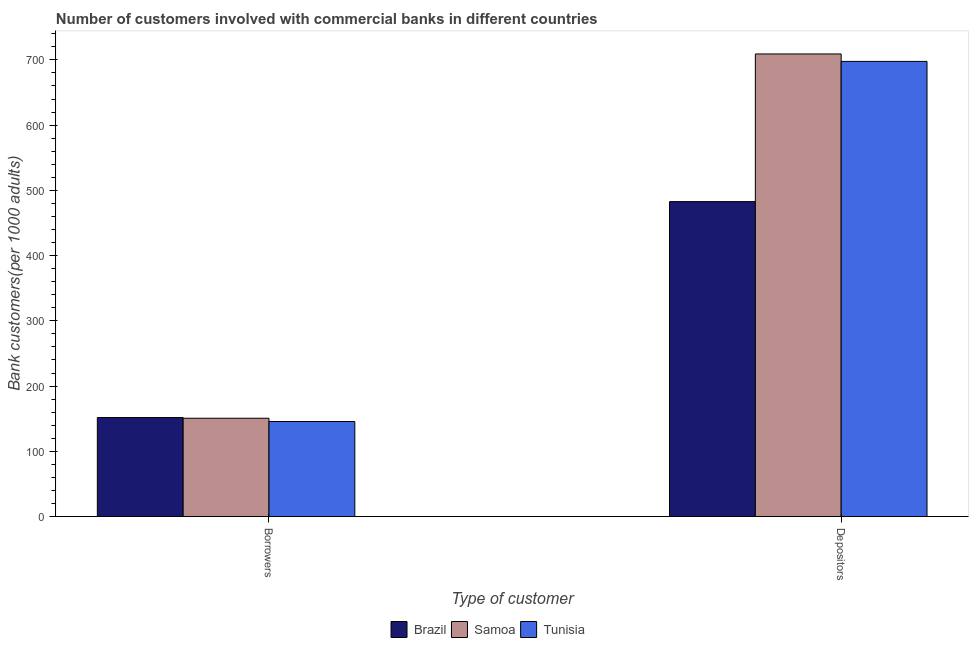How many different coloured bars are there?
Your answer should be very brief. 3. Are the number of bars on each tick of the X-axis equal?
Your answer should be very brief. Yes. What is the label of the 1st group of bars from the left?
Keep it short and to the point. Borrowers. What is the number of depositors in Samoa?
Your answer should be very brief. 709.09. Across all countries, what is the maximum number of borrowers?
Offer a very short reply. 151.74. Across all countries, what is the minimum number of borrowers?
Provide a short and direct response. 145.68. In which country was the number of depositors maximum?
Give a very brief answer. Samoa. In which country was the number of borrowers minimum?
Offer a very short reply. Tunisia. What is the total number of depositors in the graph?
Provide a short and direct response. 1889.51. What is the difference between the number of borrowers in Samoa and that in Tunisia?
Your response must be concise. 5. What is the difference between the number of borrowers in Samoa and the number of depositors in Brazil?
Your response must be concise. -332.06. What is the average number of depositors per country?
Offer a terse response. 629.84. What is the difference between the number of borrowers and number of depositors in Brazil?
Your answer should be very brief. -331. In how many countries, is the number of borrowers greater than 720 ?
Your answer should be very brief. 0. What is the ratio of the number of borrowers in Tunisia to that in Samoa?
Your answer should be compact. 0.97. Is the number of borrowers in Samoa less than that in Tunisia?
Provide a short and direct response. No. In how many countries, is the number of borrowers greater than the average number of borrowers taken over all countries?
Your response must be concise. 2. What does the 3rd bar from the left in Depositors represents?
Your answer should be compact. Tunisia. What does the 2nd bar from the right in Borrowers represents?
Ensure brevity in your answer.  Samoa. What is the difference between two consecutive major ticks on the Y-axis?
Your answer should be very brief. 100. Where does the legend appear in the graph?
Ensure brevity in your answer.  Bottom center. How many legend labels are there?
Give a very brief answer. 3. How are the legend labels stacked?
Offer a very short reply. Horizontal. What is the title of the graph?
Your answer should be very brief. Number of customers involved with commercial banks in different countries. Does "Korea (Republic)" appear as one of the legend labels in the graph?
Provide a succinct answer. No. What is the label or title of the X-axis?
Provide a succinct answer. Type of customer. What is the label or title of the Y-axis?
Offer a very short reply. Bank customers(per 1000 adults). What is the Bank customers(per 1000 adults) in Brazil in Borrowers?
Your answer should be very brief. 151.74. What is the Bank customers(per 1000 adults) of Samoa in Borrowers?
Give a very brief answer. 150.68. What is the Bank customers(per 1000 adults) of Tunisia in Borrowers?
Make the answer very short. 145.68. What is the Bank customers(per 1000 adults) in Brazil in Depositors?
Your response must be concise. 482.74. What is the Bank customers(per 1000 adults) in Samoa in Depositors?
Make the answer very short. 709.09. What is the Bank customers(per 1000 adults) of Tunisia in Depositors?
Provide a succinct answer. 697.68. Across all Type of customer, what is the maximum Bank customers(per 1000 adults) of Brazil?
Provide a succinct answer. 482.74. Across all Type of customer, what is the maximum Bank customers(per 1000 adults) in Samoa?
Keep it short and to the point. 709.09. Across all Type of customer, what is the maximum Bank customers(per 1000 adults) of Tunisia?
Your response must be concise. 697.68. Across all Type of customer, what is the minimum Bank customers(per 1000 adults) of Brazil?
Your answer should be compact. 151.74. Across all Type of customer, what is the minimum Bank customers(per 1000 adults) in Samoa?
Your answer should be very brief. 150.68. Across all Type of customer, what is the minimum Bank customers(per 1000 adults) of Tunisia?
Your response must be concise. 145.68. What is the total Bank customers(per 1000 adults) in Brazil in the graph?
Keep it short and to the point. 634.48. What is the total Bank customers(per 1000 adults) in Samoa in the graph?
Ensure brevity in your answer.  859.77. What is the total Bank customers(per 1000 adults) of Tunisia in the graph?
Your response must be concise. 843.35. What is the difference between the Bank customers(per 1000 adults) in Brazil in Borrowers and that in Depositors?
Your answer should be very brief. -331. What is the difference between the Bank customers(per 1000 adults) of Samoa in Borrowers and that in Depositors?
Offer a terse response. -558.42. What is the difference between the Bank customers(per 1000 adults) in Tunisia in Borrowers and that in Depositors?
Your answer should be very brief. -552. What is the difference between the Bank customers(per 1000 adults) of Brazil in Borrowers and the Bank customers(per 1000 adults) of Samoa in Depositors?
Make the answer very short. -557.35. What is the difference between the Bank customers(per 1000 adults) in Brazil in Borrowers and the Bank customers(per 1000 adults) in Tunisia in Depositors?
Give a very brief answer. -545.94. What is the difference between the Bank customers(per 1000 adults) in Samoa in Borrowers and the Bank customers(per 1000 adults) in Tunisia in Depositors?
Give a very brief answer. -547. What is the average Bank customers(per 1000 adults) of Brazil per Type of customer?
Offer a very short reply. 317.24. What is the average Bank customers(per 1000 adults) in Samoa per Type of customer?
Offer a very short reply. 429.88. What is the average Bank customers(per 1000 adults) in Tunisia per Type of customer?
Your answer should be very brief. 421.68. What is the difference between the Bank customers(per 1000 adults) in Brazil and Bank customers(per 1000 adults) in Samoa in Borrowers?
Offer a terse response. 1.06. What is the difference between the Bank customers(per 1000 adults) in Brazil and Bank customers(per 1000 adults) in Tunisia in Borrowers?
Give a very brief answer. 6.06. What is the difference between the Bank customers(per 1000 adults) in Samoa and Bank customers(per 1000 adults) in Tunisia in Borrowers?
Your answer should be compact. 5. What is the difference between the Bank customers(per 1000 adults) of Brazil and Bank customers(per 1000 adults) of Samoa in Depositors?
Your answer should be compact. -226.35. What is the difference between the Bank customers(per 1000 adults) of Brazil and Bank customers(per 1000 adults) of Tunisia in Depositors?
Provide a succinct answer. -214.94. What is the difference between the Bank customers(per 1000 adults) in Samoa and Bank customers(per 1000 adults) in Tunisia in Depositors?
Make the answer very short. 11.42. What is the ratio of the Bank customers(per 1000 adults) in Brazil in Borrowers to that in Depositors?
Offer a very short reply. 0.31. What is the ratio of the Bank customers(per 1000 adults) of Samoa in Borrowers to that in Depositors?
Your response must be concise. 0.21. What is the ratio of the Bank customers(per 1000 adults) of Tunisia in Borrowers to that in Depositors?
Your answer should be very brief. 0.21. What is the difference between the highest and the second highest Bank customers(per 1000 adults) in Brazil?
Provide a succinct answer. 331. What is the difference between the highest and the second highest Bank customers(per 1000 adults) of Samoa?
Provide a short and direct response. 558.42. What is the difference between the highest and the second highest Bank customers(per 1000 adults) in Tunisia?
Make the answer very short. 552. What is the difference between the highest and the lowest Bank customers(per 1000 adults) of Brazil?
Provide a succinct answer. 331. What is the difference between the highest and the lowest Bank customers(per 1000 adults) of Samoa?
Provide a short and direct response. 558.42. What is the difference between the highest and the lowest Bank customers(per 1000 adults) of Tunisia?
Offer a terse response. 552. 